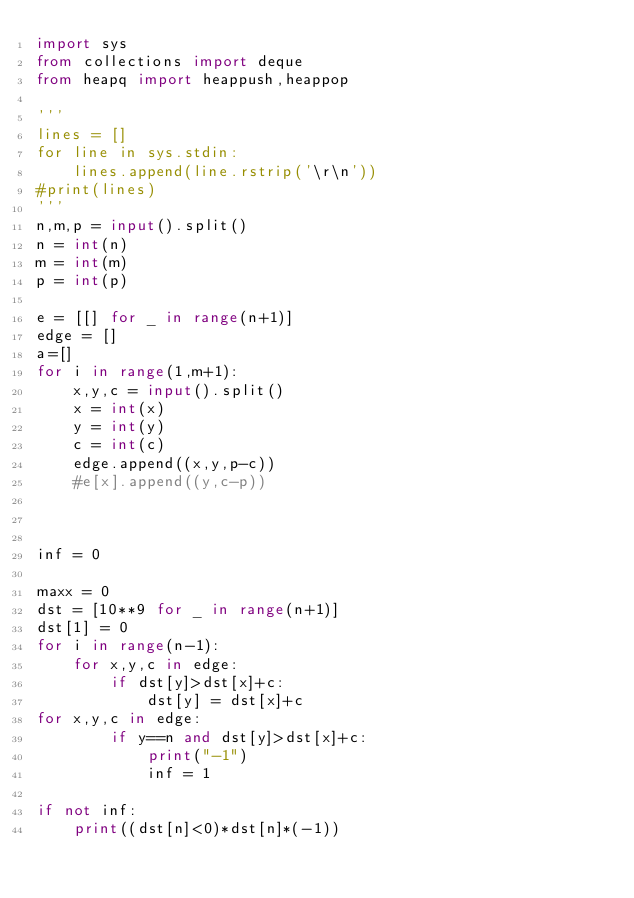<code> <loc_0><loc_0><loc_500><loc_500><_Python_>import sys
from collections import deque
from heapq import heappush,heappop

'''
lines = []
for line in sys.stdin:
    lines.append(line.rstrip('\r\n'))
#print(lines)
'''
n,m,p = input().split()
n = int(n)
m = int(m)
p = int(p)

e = [[] for _ in range(n+1)]
edge = []
a=[]
for i in range(1,m+1):
    x,y,c = input().split()
    x = int(x)
    y = int(y)
    c = int(c)
    edge.append((x,y,p-c))
    #e[x].append((y,c-p))



inf = 0

maxx = 0
dst = [10**9 for _ in range(n+1)]
dst[1] = 0
for i in range(n-1):
    for x,y,c in edge:
        if dst[y]>dst[x]+c:
            dst[y] = dst[x]+c
for x,y,c in edge:
        if y==n and dst[y]>dst[x]+c:
            print("-1")
            inf = 1

if not inf:
    print((dst[n]<0)*dst[n]*(-1))

</code> 